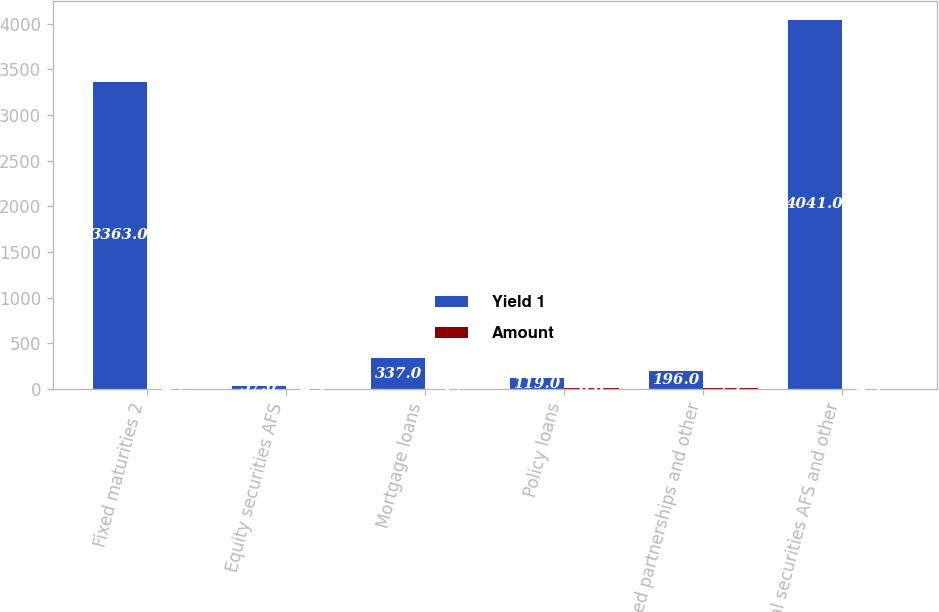Convert chart. <chart><loc_0><loc_0><loc_500><loc_500><stacked_bar_chart><ecel><fcel>Fixed maturities 2<fcel>Equity securities AFS<fcel>Mortgage loans<fcel>Policy loans<fcel>Limited partnerships and other<fcel>Total securities AFS and other<nl><fcel>Yield 1<fcel>3363<fcel>37<fcel>337<fcel>119<fcel>196<fcel>4041<nl><fcel>Amount<fcel>4.2<fcel>4.3<fcel>5.2<fcel>6<fcel>7.1<fcel>4.3<nl></chart> 